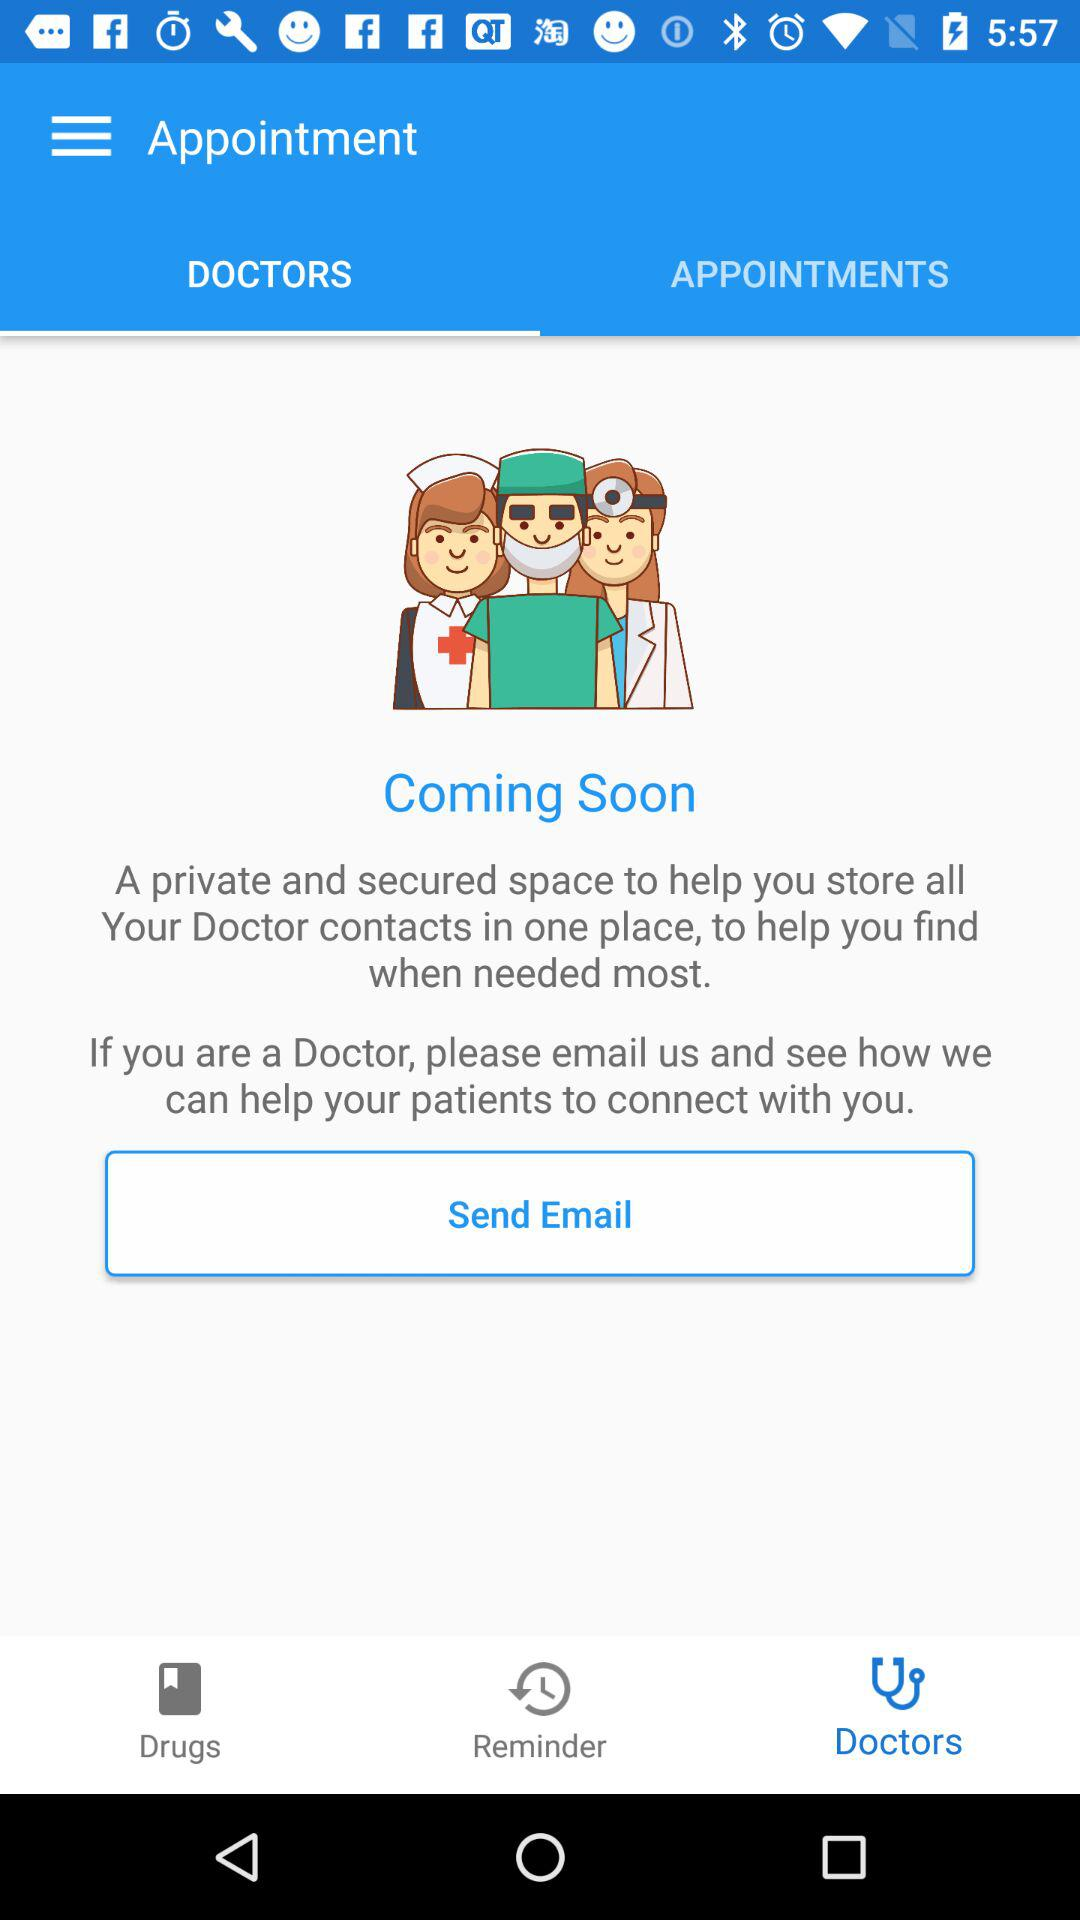Which tab is selected? The selected tab is "DOCTORS". 